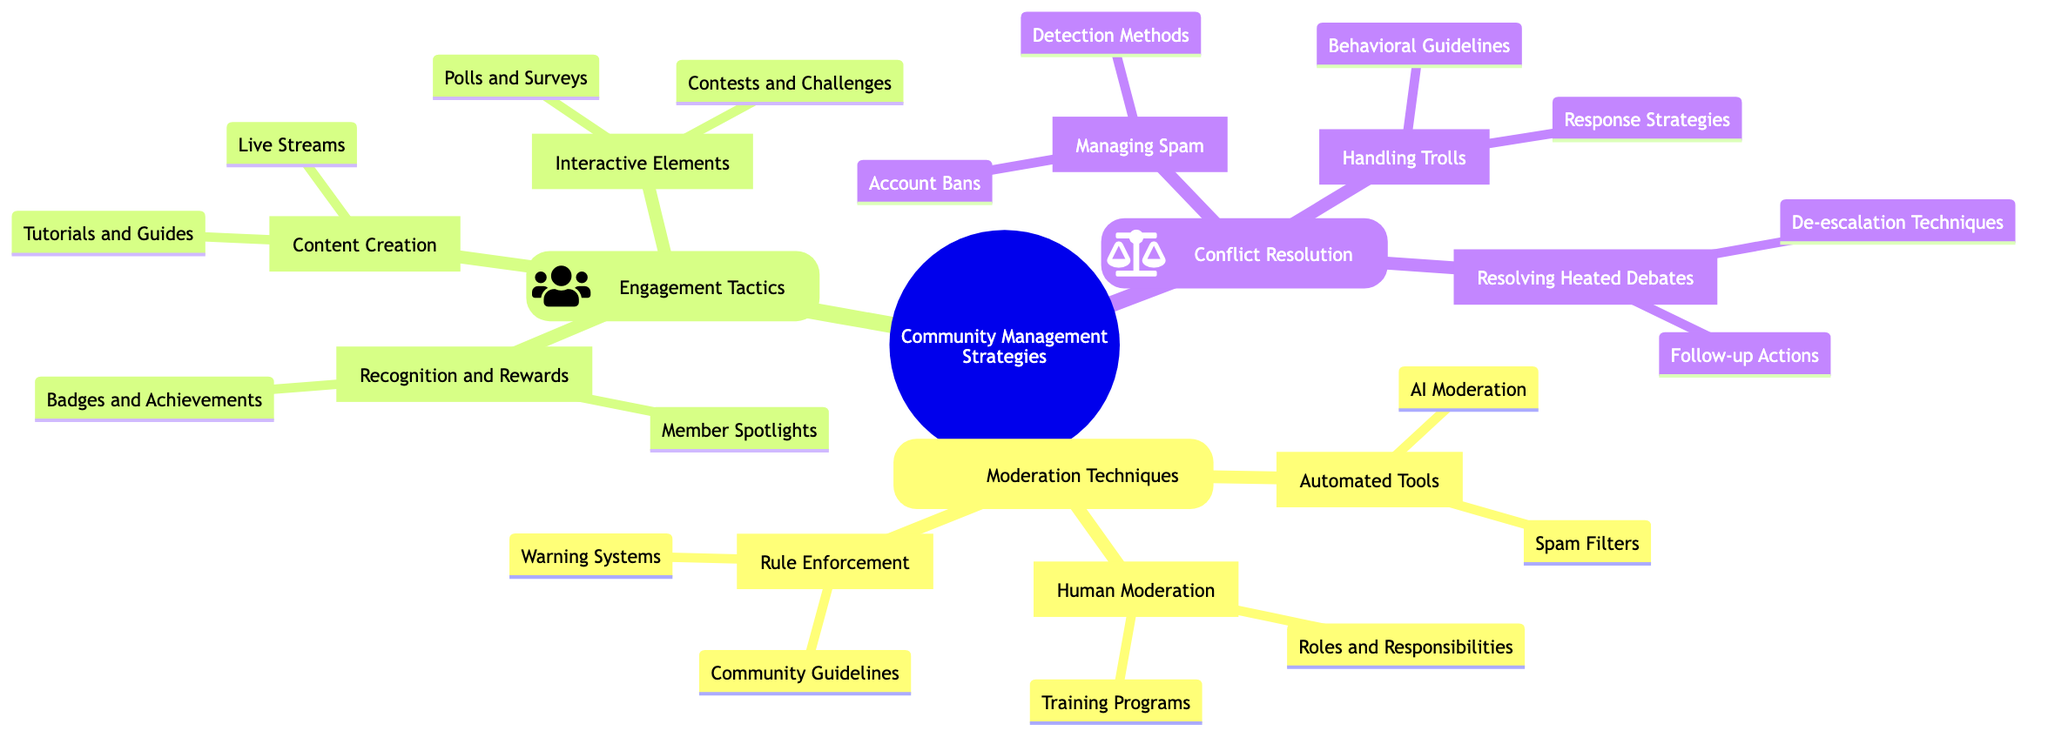What are some examples of automated tools listed? The node "Automated Tools" under "Moderation Techniques" contains two examples: "Spam Filters" and "AI Moderation."
Answer: Spam Filters, AI Moderation How many types of conflict resolution strategies are mentioned? The "Conflict Resolution" section lists three strategies: "Managing Spam," "Handling Trolls," and "Resolving Heated Debates." Thus, the count is three.
Answer: 3 What is an example of a recognition tactic mentioned? The "Recognition and Rewards" section includes "Member Spotlights" as an example of a tactic used to engage community members.
Answer: Member Spotlights What are the detection methods for managing spam? Under "Managing Spam," the listed detection methods are "Real-time Monitoring" and "User Reports." These methods help moderators identify spam posts effectively.
Answer: Real-time Monitoring, User Reports What is the main focus of the "Engagement Tactics" category? "Engagement Tactics" focuses on strategies like content creation, interactive elements, and recognition methods to enhance community interaction and participation.
Answer: Content Creation, Interactive Elements, Recognition Which tactic involves Contests and Challenges? The "Interactive Elements" category mentions "Contests and Challenges" as a tactic aimed at engaging community members through competitions and creative challenges.
Answer: Contests and Challenges How many roles are mentioned under Human Moderation? The "Human Moderation" section specifies three roles: "Moderator," "Super Moderator," and "Admin." Thus, the total count of roles is three.
Answer: 3 What is a warning system mentioned in the moderation techniques? The "Warning Systems" under "Rule Enforcement" specifies the "Three-Strike Policy" as a method for warning members before further action is taken.
Answer: Three-Strike Policy What is a behavioral guideline for handling trolls? The "Behavioral Guidelines" listed under "Handling Trolls" include "Respectful Communication Policy," which sets the standard for acceptable member interaction and discourages negative behavior.
Answer: Respectful Communication Policy 